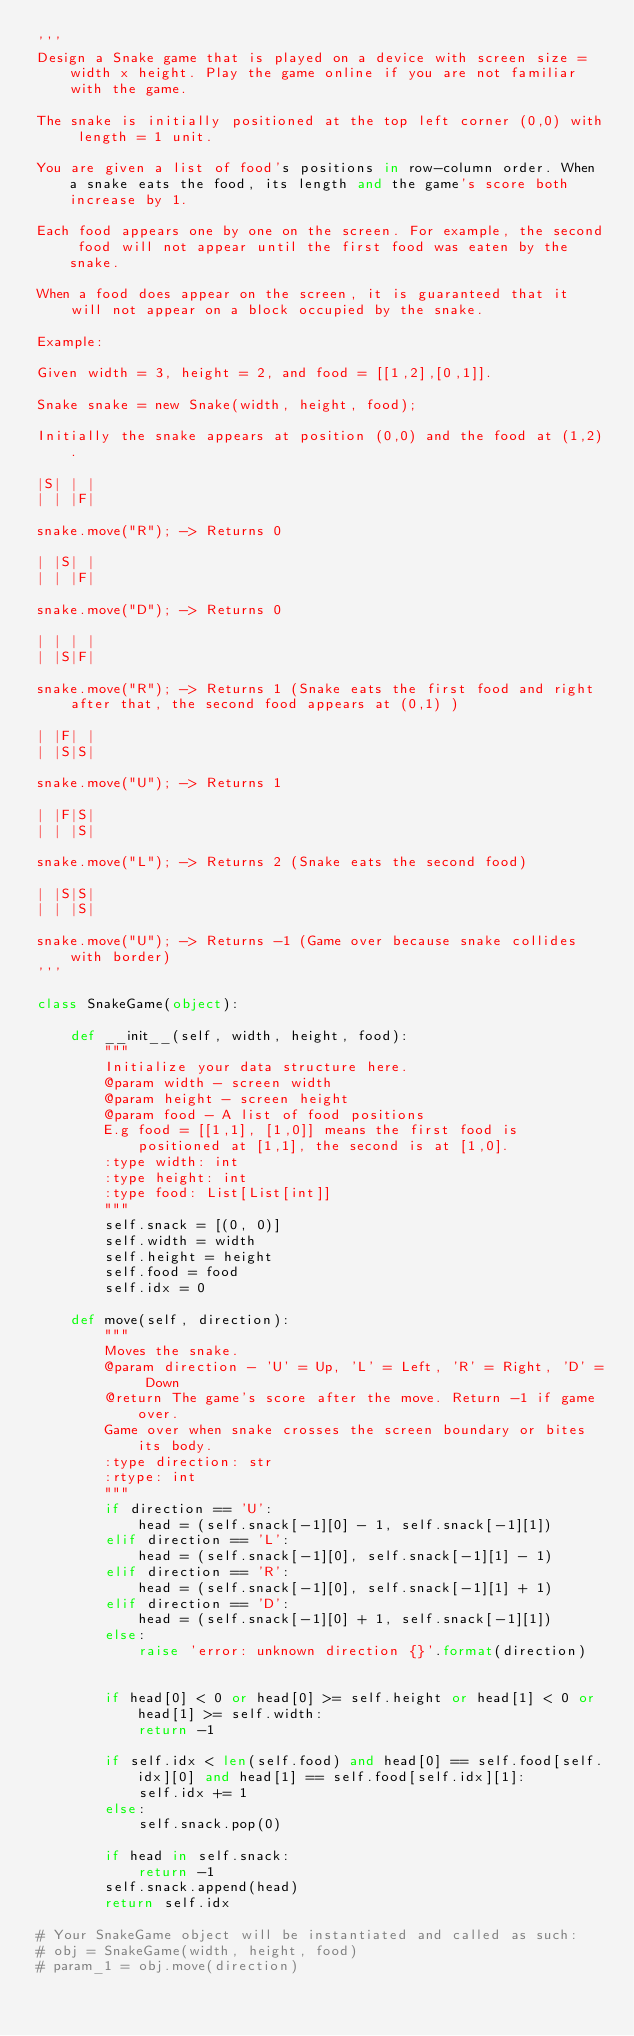<code> <loc_0><loc_0><loc_500><loc_500><_Python_>'''
Design a Snake game that is played on a device with screen size = width x height. Play the game online if you are not familiar with the game.

The snake is initially positioned at the top left corner (0,0) with length = 1 unit.

You are given a list of food's positions in row-column order. When a snake eats the food, its length and the game's score both increase by 1.

Each food appears one by one on the screen. For example, the second food will not appear until the first food was eaten by the snake.

When a food does appear on the screen, it is guaranteed that it will not appear on a block occupied by the snake.

Example:

Given width = 3, height = 2, and food = [[1,2],[0,1]].

Snake snake = new Snake(width, height, food);

Initially the snake appears at position (0,0) and the food at (1,2).

|S| | |
| | |F|

snake.move("R"); -> Returns 0

| |S| |
| | |F|

snake.move("D"); -> Returns 0

| | | |
| |S|F|

snake.move("R"); -> Returns 1 (Snake eats the first food and right after that, the second food appears at (0,1) )

| |F| |
| |S|S|

snake.move("U"); -> Returns 1

| |F|S|
| | |S|

snake.move("L"); -> Returns 2 (Snake eats the second food)

| |S|S|
| | |S|

snake.move("U"); -> Returns -1 (Game over because snake collides with border)
'''

class SnakeGame(object):

    def __init__(self, width, height, food):
        """
        Initialize your data structure here.
        @param width - screen width
        @param height - screen height 
        @param food - A list of food positions
        E.g food = [[1,1], [1,0]] means the first food is positioned at [1,1], the second is at [1,0].
        :type width: int
        :type height: int
        :type food: List[List[int]]
        """
        self.snack = [(0, 0)]
        self.width = width
        self.height = height
        self.food = food
        self.idx = 0

    def move(self, direction):
        """
        Moves the snake.
        @param direction - 'U' = Up, 'L' = Left, 'R' = Right, 'D' = Down 
        @return The game's score after the move. Return -1 if game over. 
        Game over when snake crosses the screen boundary or bites its body.
        :type direction: str
        :rtype: int
        """
        if direction == 'U':
            head = (self.snack[-1][0] - 1, self.snack[-1][1])
        elif direction == 'L':
            head = (self.snack[-1][0], self.snack[-1][1] - 1)
        elif direction == 'R':
            head = (self.snack[-1][0], self.snack[-1][1] + 1)
        elif direction == 'D':
            head = (self.snack[-1][0] + 1, self.snack[-1][1])
        else:
            raise 'error: unknown direction {}'.format(direction)
        

        if head[0] < 0 or head[0] >= self.height or head[1] < 0 or head[1] >= self.width:
            return -1
        
        if self.idx < len(self.food) and head[0] == self.food[self.idx][0] and head[1] == self.food[self.idx][1]:
            self.idx += 1
        else:
            self.snack.pop(0)
            
        if head in self.snack:
            return -1
        self.snack.append(head)
        return self.idx

# Your SnakeGame object will be instantiated and called as such:
# obj = SnakeGame(width, height, food)
# param_1 = obj.move(direction)
</code> 